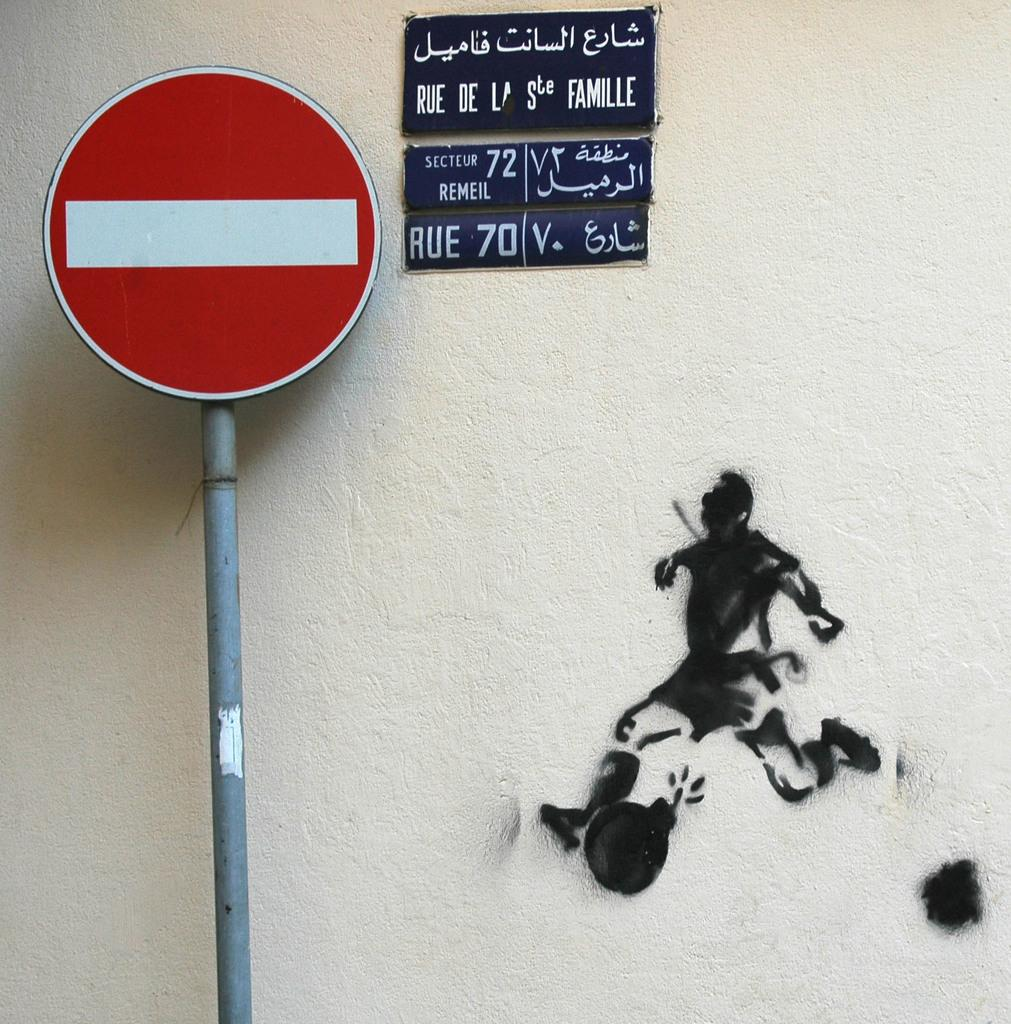<image>
Give a short and clear explanation of the subsequent image. A black sign on the wall displays the word RUE towards the bottom, left corner. 